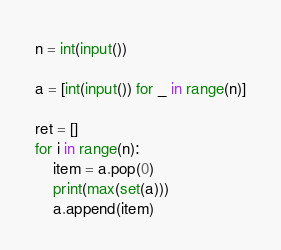Convert code to text. <code><loc_0><loc_0><loc_500><loc_500><_Python_>n = int(input())

a = [int(input()) for _ in range(n)]

ret = []
for i in range(n):
    item = a.pop(0)
    print(max(set(a)))
    a.append(item)</code> 